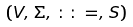Convert formula to latex. <formula><loc_0><loc_0><loc_500><loc_500>( V , \, \Sigma , \, \colon \colon = , \, S )</formula> 